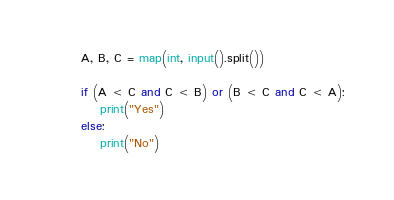Convert code to text. <code><loc_0><loc_0><loc_500><loc_500><_Python_>A, B, C = map(int, input().split())

if (A < C and C < B) or (B < C and C < A):
    print("Yes")
else:
    print("No")
</code> 